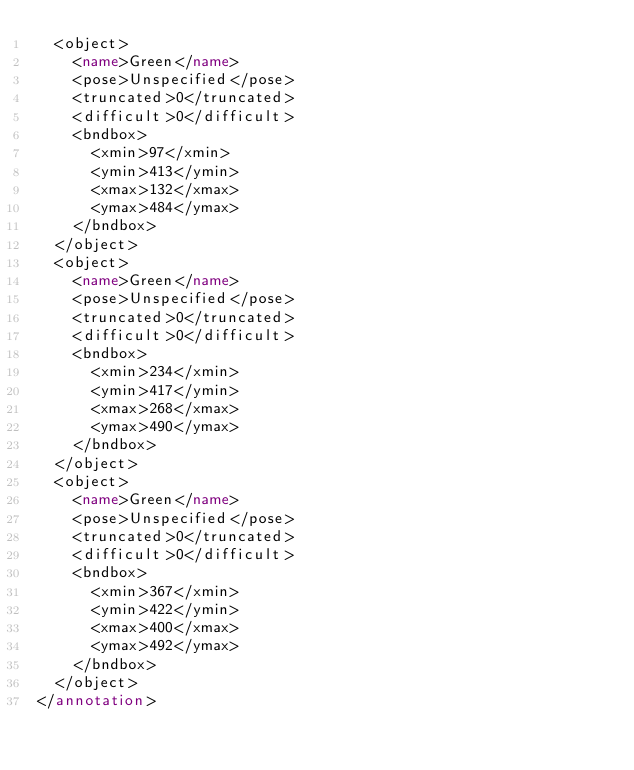<code> <loc_0><loc_0><loc_500><loc_500><_XML_>	<object>
		<name>Green</name>
		<pose>Unspecified</pose>
		<truncated>0</truncated>
		<difficult>0</difficult>
		<bndbox>
			<xmin>97</xmin>
			<ymin>413</ymin>
			<xmax>132</xmax>
			<ymax>484</ymax>
		</bndbox>
	</object>
	<object>
		<name>Green</name>
		<pose>Unspecified</pose>
		<truncated>0</truncated>
		<difficult>0</difficult>
		<bndbox>
			<xmin>234</xmin>
			<ymin>417</ymin>
			<xmax>268</xmax>
			<ymax>490</ymax>
		</bndbox>
	</object>
	<object>
		<name>Green</name>
		<pose>Unspecified</pose>
		<truncated>0</truncated>
		<difficult>0</difficult>
		<bndbox>
			<xmin>367</xmin>
			<ymin>422</ymin>
			<xmax>400</xmax>
			<ymax>492</ymax>
		</bndbox>
	</object>
</annotation>
</code> 